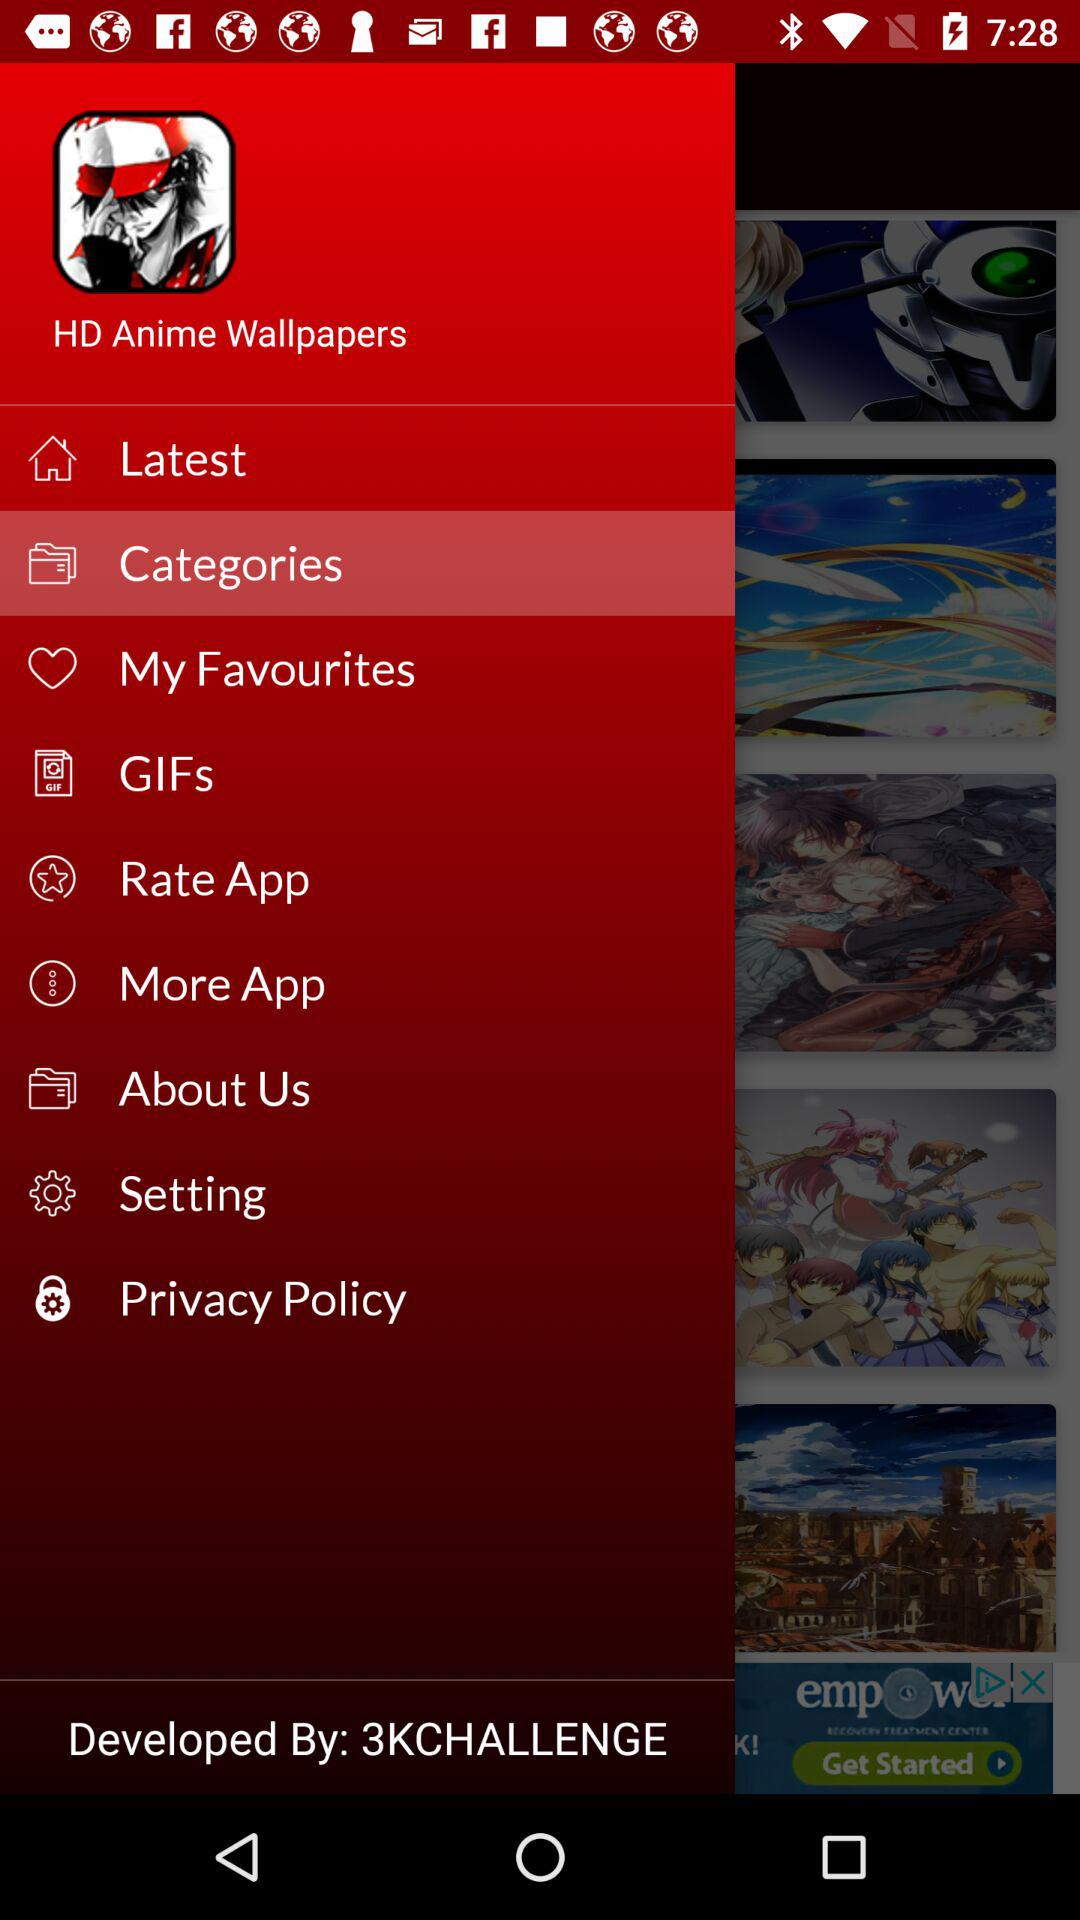Who developed the application? The application is developed by "3KCHALLENGE". 